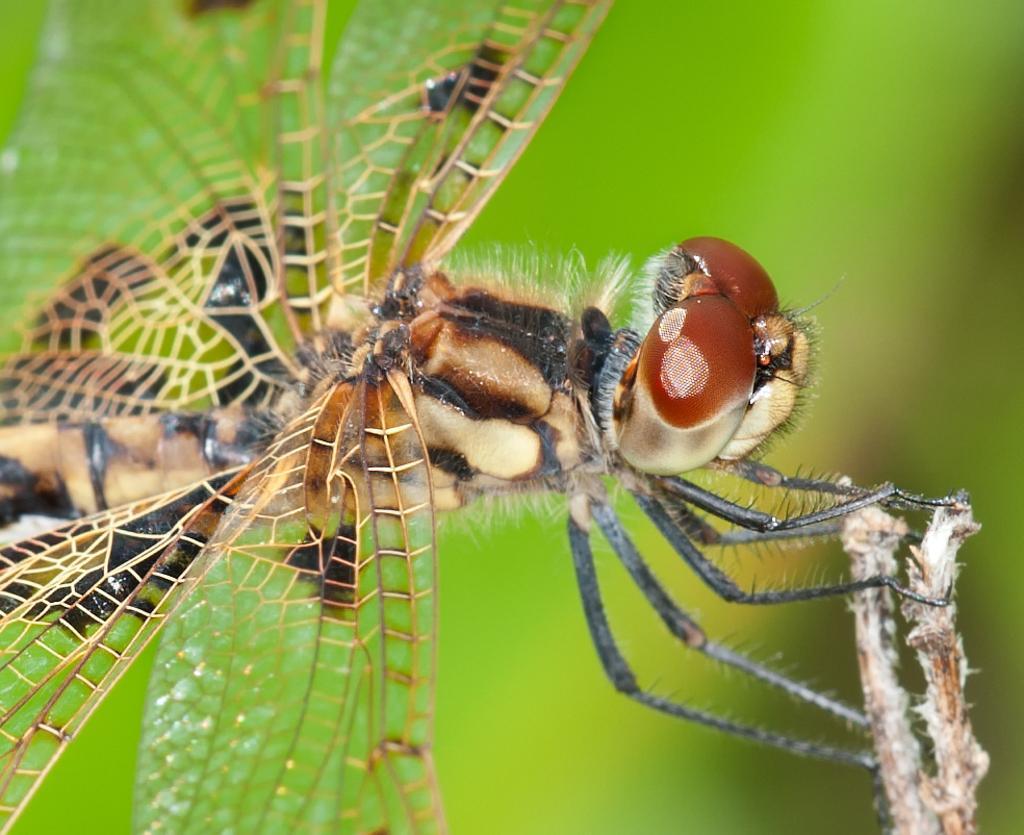Please provide a concise description of this image. In this image I can see an insect in black and brown color and I can see green color background. 